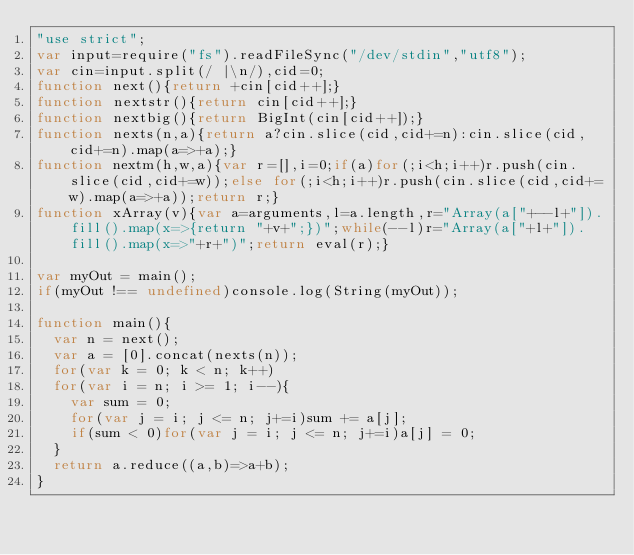Convert code to text. <code><loc_0><loc_0><loc_500><loc_500><_JavaScript_>"use strict";
var input=require("fs").readFileSync("/dev/stdin","utf8");
var cin=input.split(/ |\n/),cid=0;
function next(){return +cin[cid++];}
function nextstr(){return cin[cid++];}
function nextbig(){return BigInt(cin[cid++]);}
function nexts(n,a){return a?cin.slice(cid,cid+=n):cin.slice(cid,cid+=n).map(a=>+a);}
function nextm(h,w,a){var r=[],i=0;if(a)for(;i<h;i++)r.push(cin.slice(cid,cid+=w));else for(;i<h;i++)r.push(cin.slice(cid,cid+=w).map(a=>+a));return r;}
function xArray(v){var a=arguments,l=a.length,r="Array(a["+--l+"]).fill().map(x=>{return "+v+";})";while(--l)r="Array(a["+l+"]).fill().map(x=>"+r+")";return eval(r);}

var myOut = main();
if(myOut !== undefined)console.log(String(myOut));

function main(){
  var n = next();
  var a = [0].concat(nexts(n));
  for(var k = 0; k < n; k++)
  for(var i = n; i >= 1; i--){
    var sum = 0;
    for(var j = i; j <= n; j+=i)sum += a[j];
    if(sum < 0)for(var j = i; j <= n; j+=i)a[j] = 0;
  }
  return a.reduce((a,b)=>a+b);
}</code> 